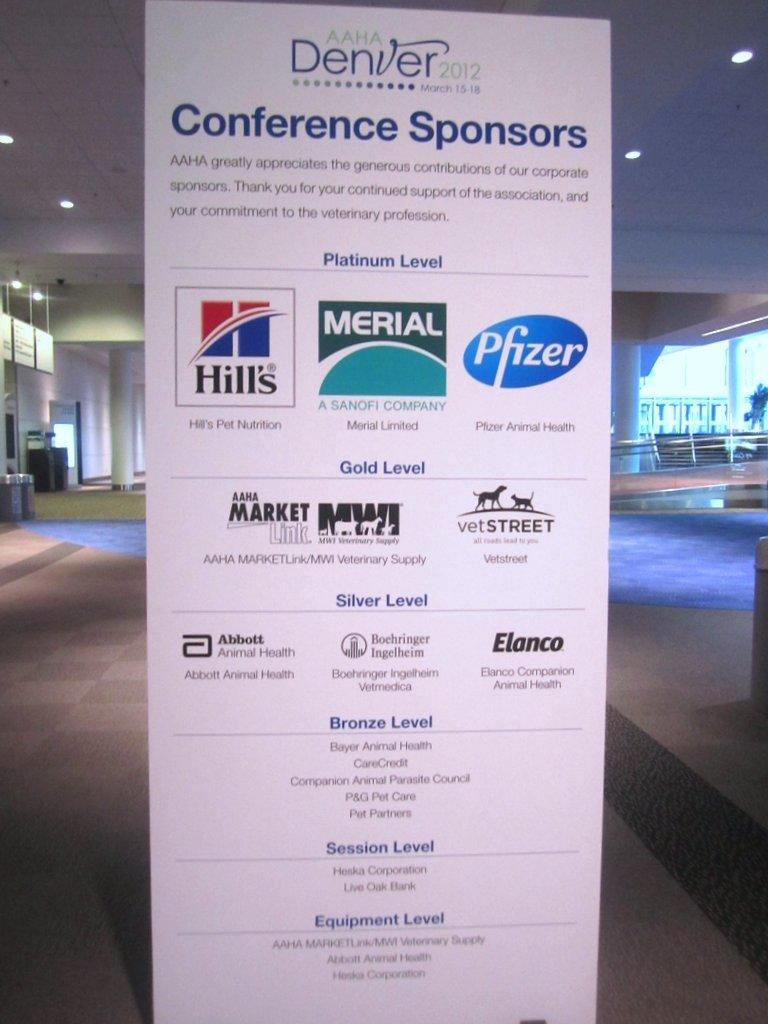<image>
Describe the image concisely. Tall sign that says AAHA Denver for the year 2012. 